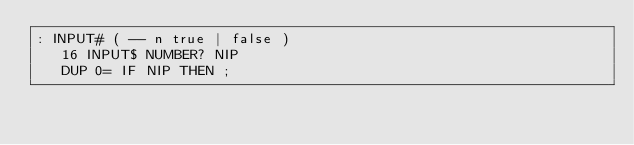Convert code to text. <code><loc_0><loc_0><loc_500><loc_500><_Forth_>: INPUT# ( -- n true | false )
   16 INPUT$ NUMBER? NIP
   DUP 0= IF NIP THEN ;
</code> 